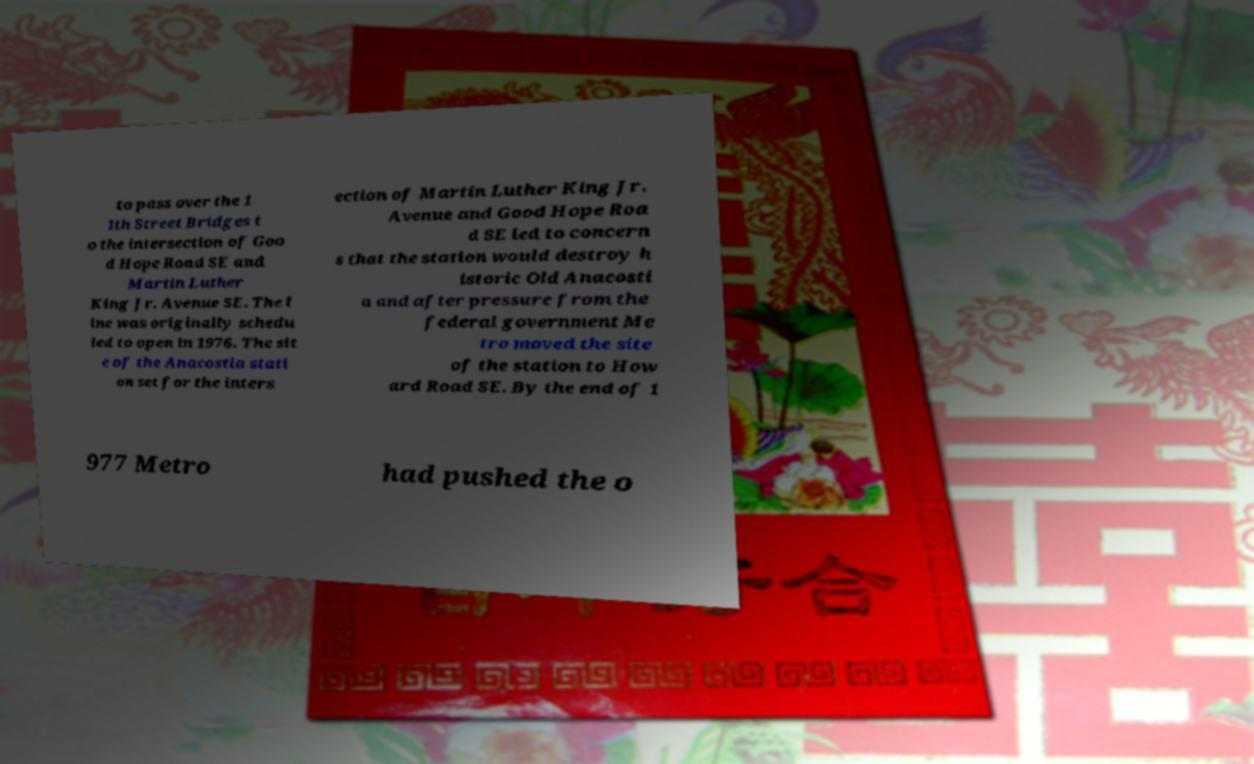Can you accurately transcribe the text from the provided image for me? to pass over the 1 1th Street Bridges t o the intersection of Goo d Hope Road SE and Martin Luther King Jr. Avenue SE. The l ine was originally schedu led to open in 1976. The sit e of the Anacostia stati on set for the inters ection of Martin Luther King Jr. Avenue and Good Hope Roa d SE led to concern s that the station would destroy h istoric Old Anacosti a and after pressure from the federal government Me tro moved the site of the station to How ard Road SE. By the end of 1 977 Metro had pushed the o 